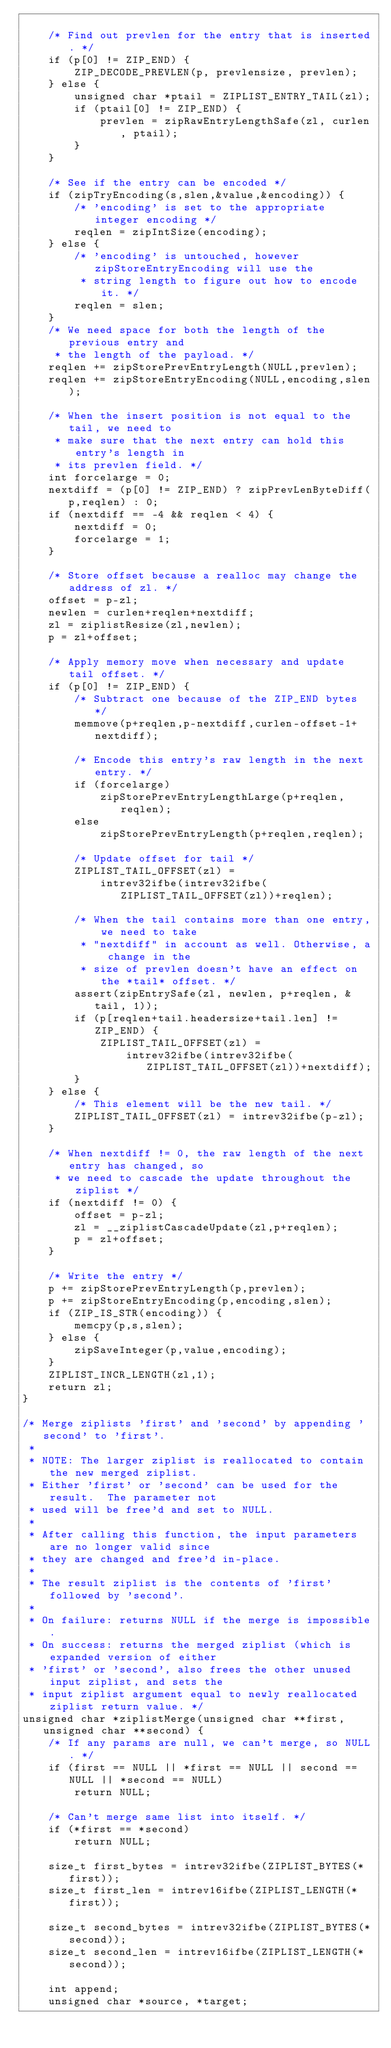Convert code to text. <code><loc_0><loc_0><loc_500><loc_500><_C_>
    /* Find out prevlen for the entry that is inserted. */
    if (p[0] != ZIP_END) {
        ZIP_DECODE_PREVLEN(p, prevlensize, prevlen);
    } else {
        unsigned char *ptail = ZIPLIST_ENTRY_TAIL(zl);
        if (ptail[0] != ZIP_END) {
            prevlen = zipRawEntryLengthSafe(zl, curlen, ptail);
        }
    }

    /* See if the entry can be encoded */
    if (zipTryEncoding(s,slen,&value,&encoding)) {
        /* 'encoding' is set to the appropriate integer encoding */
        reqlen = zipIntSize(encoding);
    } else {
        /* 'encoding' is untouched, however zipStoreEntryEncoding will use the
         * string length to figure out how to encode it. */
        reqlen = slen;
    }
    /* We need space for both the length of the previous entry and
     * the length of the payload. */
    reqlen += zipStorePrevEntryLength(NULL,prevlen);
    reqlen += zipStoreEntryEncoding(NULL,encoding,slen);

    /* When the insert position is not equal to the tail, we need to
     * make sure that the next entry can hold this entry's length in
     * its prevlen field. */
    int forcelarge = 0;
    nextdiff = (p[0] != ZIP_END) ? zipPrevLenByteDiff(p,reqlen) : 0;
    if (nextdiff == -4 && reqlen < 4) {
        nextdiff = 0;
        forcelarge = 1;
    }

    /* Store offset because a realloc may change the address of zl. */
    offset = p-zl;
    newlen = curlen+reqlen+nextdiff;
    zl = ziplistResize(zl,newlen);
    p = zl+offset;

    /* Apply memory move when necessary and update tail offset. */
    if (p[0] != ZIP_END) {
        /* Subtract one because of the ZIP_END bytes */
        memmove(p+reqlen,p-nextdiff,curlen-offset-1+nextdiff);

        /* Encode this entry's raw length in the next entry. */
        if (forcelarge)
            zipStorePrevEntryLengthLarge(p+reqlen,reqlen);
        else
            zipStorePrevEntryLength(p+reqlen,reqlen);

        /* Update offset for tail */
        ZIPLIST_TAIL_OFFSET(zl) =
            intrev32ifbe(intrev32ifbe(ZIPLIST_TAIL_OFFSET(zl))+reqlen);

        /* When the tail contains more than one entry, we need to take
         * "nextdiff" in account as well. Otherwise, a change in the
         * size of prevlen doesn't have an effect on the *tail* offset. */
        assert(zipEntrySafe(zl, newlen, p+reqlen, &tail, 1));
        if (p[reqlen+tail.headersize+tail.len] != ZIP_END) {
            ZIPLIST_TAIL_OFFSET(zl) =
                intrev32ifbe(intrev32ifbe(ZIPLIST_TAIL_OFFSET(zl))+nextdiff);
        }
    } else {
        /* This element will be the new tail. */
        ZIPLIST_TAIL_OFFSET(zl) = intrev32ifbe(p-zl);
    }

    /* When nextdiff != 0, the raw length of the next entry has changed, so
     * we need to cascade the update throughout the ziplist */
    if (nextdiff != 0) {
        offset = p-zl;
        zl = __ziplistCascadeUpdate(zl,p+reqlen);
        p = zl+offset;
    }

    /* Write the entry */
    p += zipStorePrevEntryLength(p,prevlen);
    p += zipStoreEntryEncoding(p,encoding,slen);
    if (ZIP_IS_STR(encoding)) {
        memcpy(p,s,slen);
    } else {
        zipSaveInteger(p,value,encoding);
    }
    ZIPLIST_INCR_LENGTH(zl,1);
    return zl;
}

/* Merge ziplists 'first' and 'second' by appending 'second' to 'first'.
 *
 * NOTE: The larger ziplist is reallocated to contain the new merged ziplist.
 * Either 'first' or 'second' can be used for the result.  The parameter not
 * used will be free'd and set to NULL.
 *
 * After calling this function, the input parameters are no longer valid since
 * they are changed and free'd in-place.
 *
 * The result ziplist is the contents of 'first' followed by 'second'.
 *
 * On failure: returns NULL if the merge is impossible.
 * On success: returns the merged ziplist (which is expanded version of either
 * 'first' or 'second', also frees the other unused input ziplist, and sets the
 * input ziplist argument equal to newly reallocated ziplist return value. */
unsigned char *ziplistMerge(unsigned char **first, unsigned char **second) {
    /* If any params are null, we can't merge, so NULL. */
    if (first == NULL || *first == NULL || second == NULL || *second == NULL)
        return NULL;

    /* Can't merge same list into itself. */
    if (*first == *second)
        return NULL;

    size_t first_bytes = intrev32ifbe(ZIPLIST_BYTES(*first));
    size_t first_len = intrev16ifbe(ZIPLIST_LENGTH(*first));

    size_t second_bytes = intrev32ifbe(ZIPLIST_BYTES(*second));
    size_t second_len = intrev16ifbe(ZIPLIST_LENGTH(*second));

    int append;
    unsigned char *source, *target;</code> 